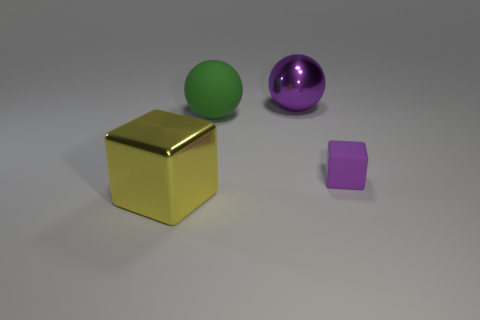Is there anything else that has the same shape as the big purple thing?
Give a very brief answer. Yes. Is the number of large shiny cubes less than the number of large green metallic blocks?
Offer a terse response. No. What is the thing that is both in front of the rubber sphere and behind the yellow shiny block made of?
Your answer should be very brief. Rubber. There is a purple matte thing that is in front of the large purple metallic sphere; is there a green sphere on the right side of it?
Ensure brevity in your answer.  No. How many things are cyan spheres or yellow objects?
Your answer should be very brief. 1. What shape is the thing that is both in front of the large rubber object and right of the yellow cube?
Offer a very short reply. Cube. Do the ball that is to the left of the big purple shiny sphere and the big purple thing have the same material?
Keep it short and to the point. No. How many things are either big cyan spheres or large objects that are behind the purple matte cube?
Keep it short and to the point. 2. There is a large ball that is made of the same material as the yellow object; what is its color?
Your answer should be compact. Purple. What number of tiny brown spheres have the same material as the big green ball?
Offer a terse response. 0. 